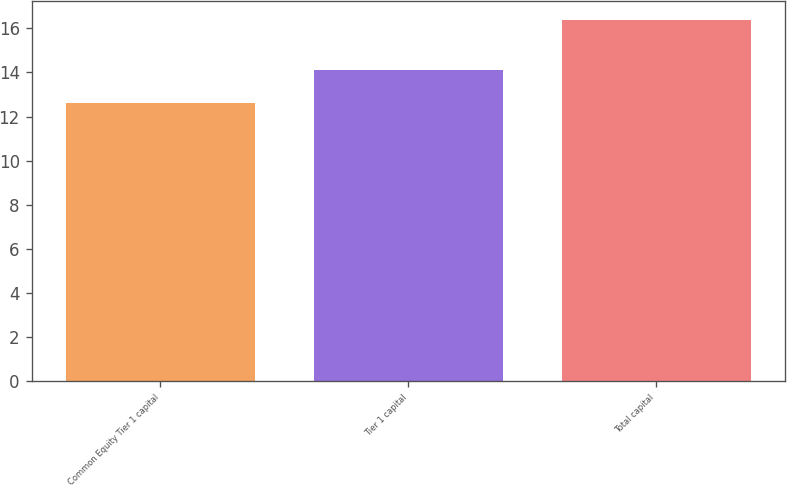Convert chart to OTSL. <chart><loc_0><loc_0><loc_500><loc_500><bar_chart><fcel>Common Equity Tier 1 capital<fcel>Tier 1 capital<fcel>Total capital<nl><fcel>12.6<fcel>14.1<fcel>16.4<nl></chart> 